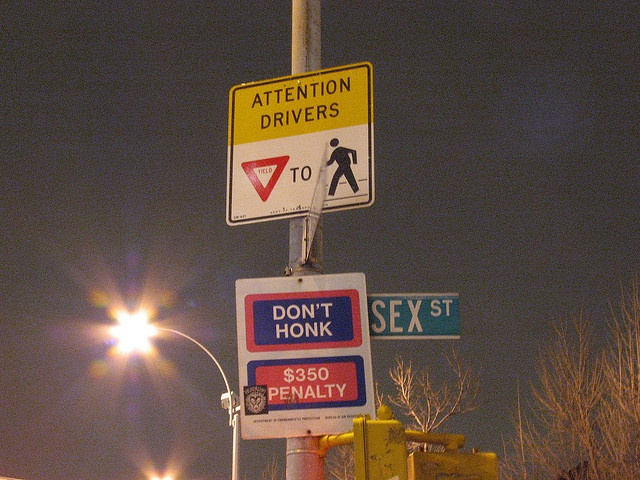Describe the objects in this image and their specific colors. I can see a traffic light in black, olive, maroon, and orange tones in this image. 